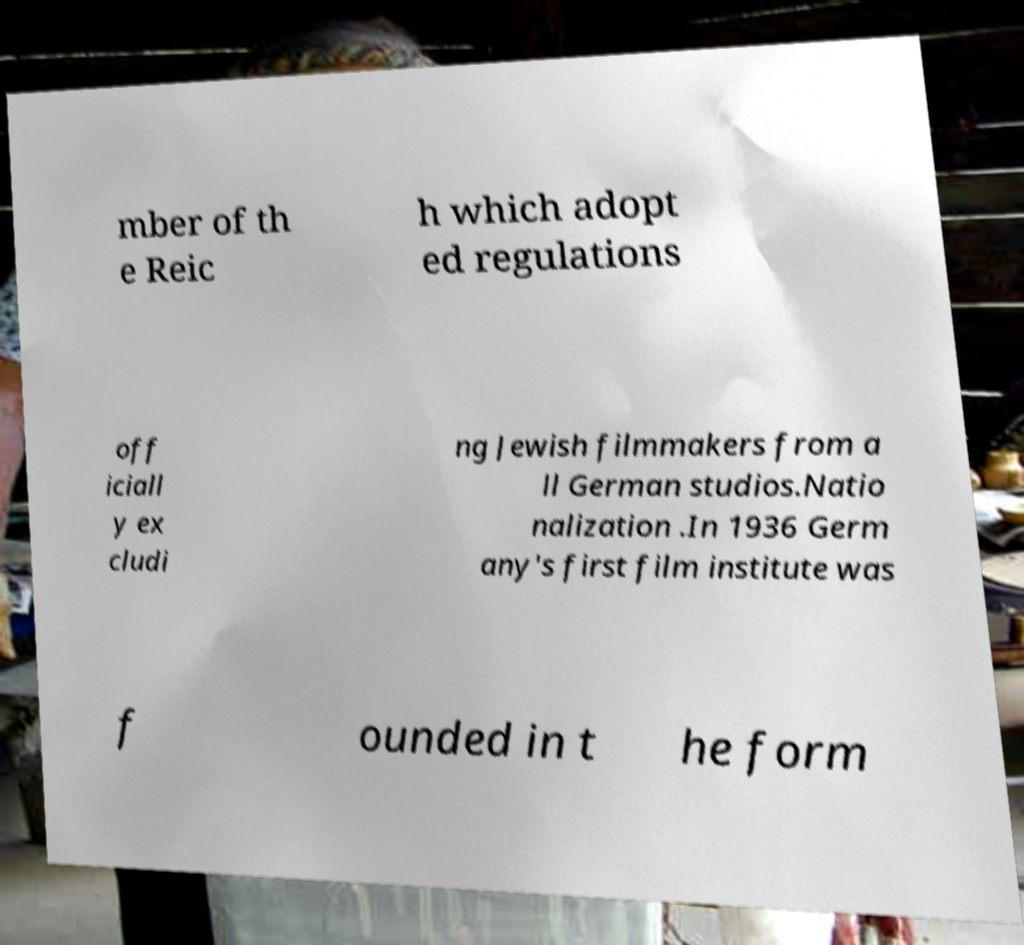Can you read and provide the text displayed in the image?This photo seems to have some interesting text. Can you extract and type it out for me? mber of th e Reic h which adopt ed regulations off iciall y ex cludi ng Jewish filmmakers from a ll German studios.Natio nalization .In 1936 Germ any's first film institute was f ounded in t he form 